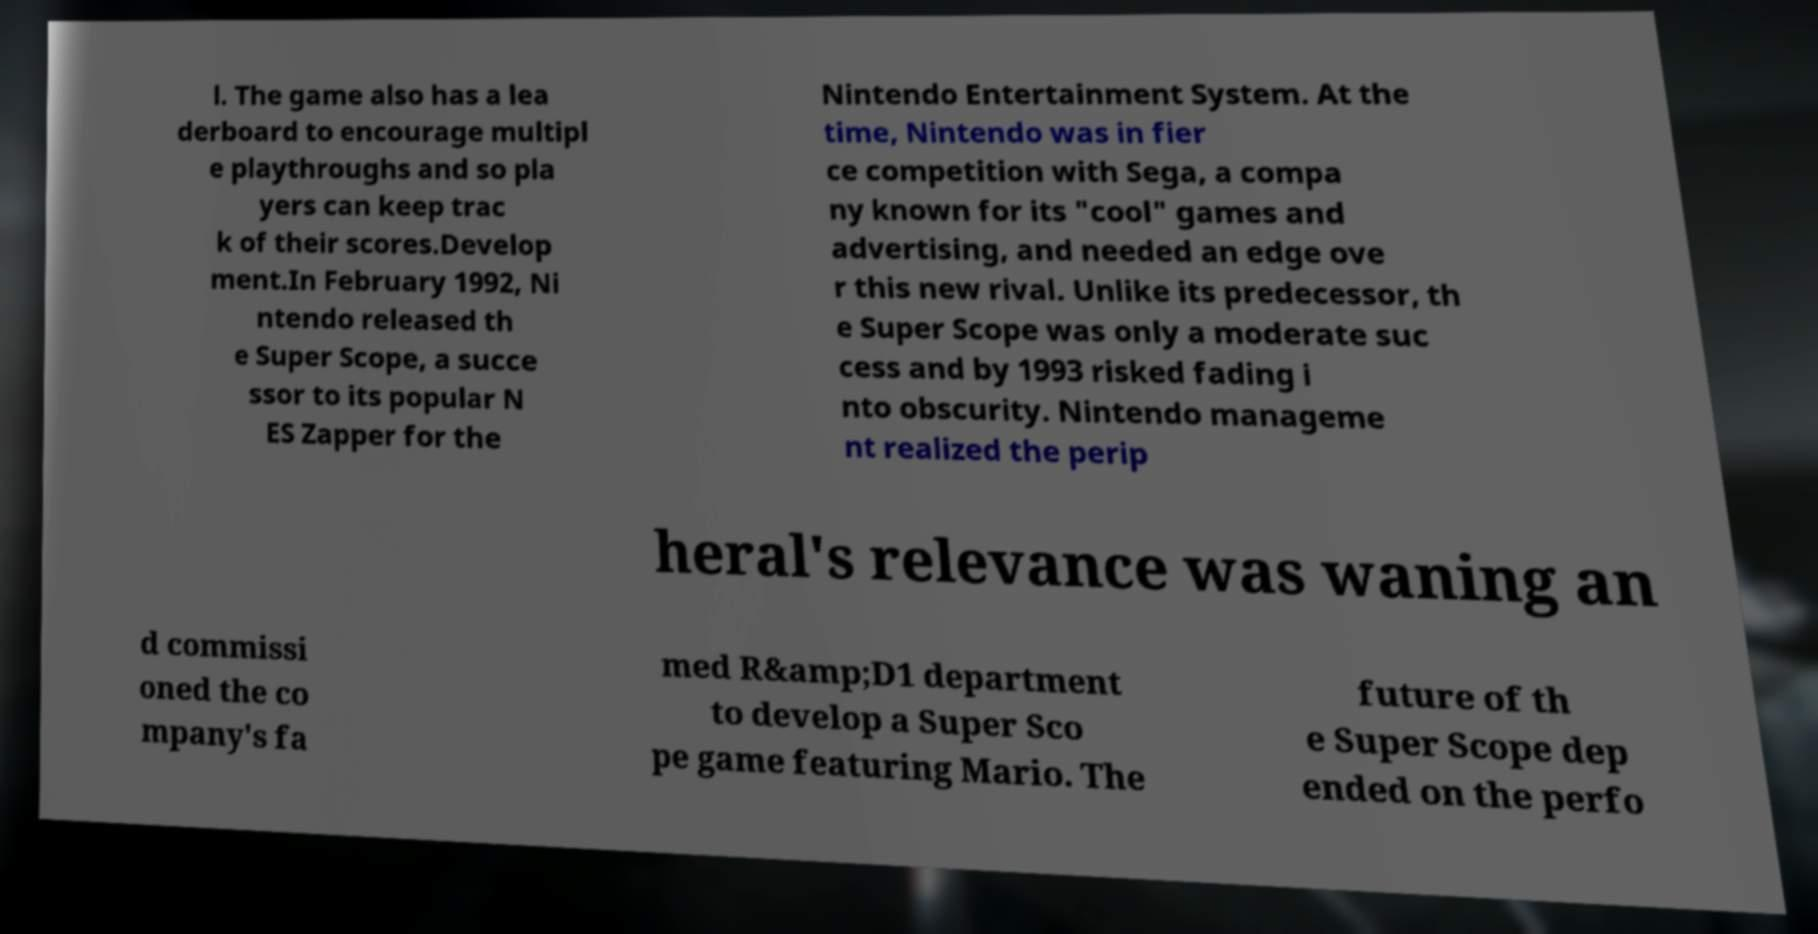Can you accurately transcribe the text from the provided image for me? l. The game also has a lea derboard to encourage multipl e playthroughs and so pla yers can keep trac k of their scores.Develop ment.In February 1992, Ni ntendo released th e Super Scope, a succe ssor to its popular N ES Zapper for the Nintendo Entertainment System. At the time, Nintendo was in fier ce competition with Sega, a compa ny known for its "cool" games and advertising, and needed an edge ove r this new rival. Unlike its predecessor, th e Super Scope was only a moderate suc cess and by 1993 risked fading i nto obscurity. Nintendo manageme nt realized the perip heral's relevance was waning an d commissi oned the co mpany's fa med R&amp;D1 department to develop a Super Sco pe game featuring Mario. The future of th e Super Scope dep ended on the perfo 